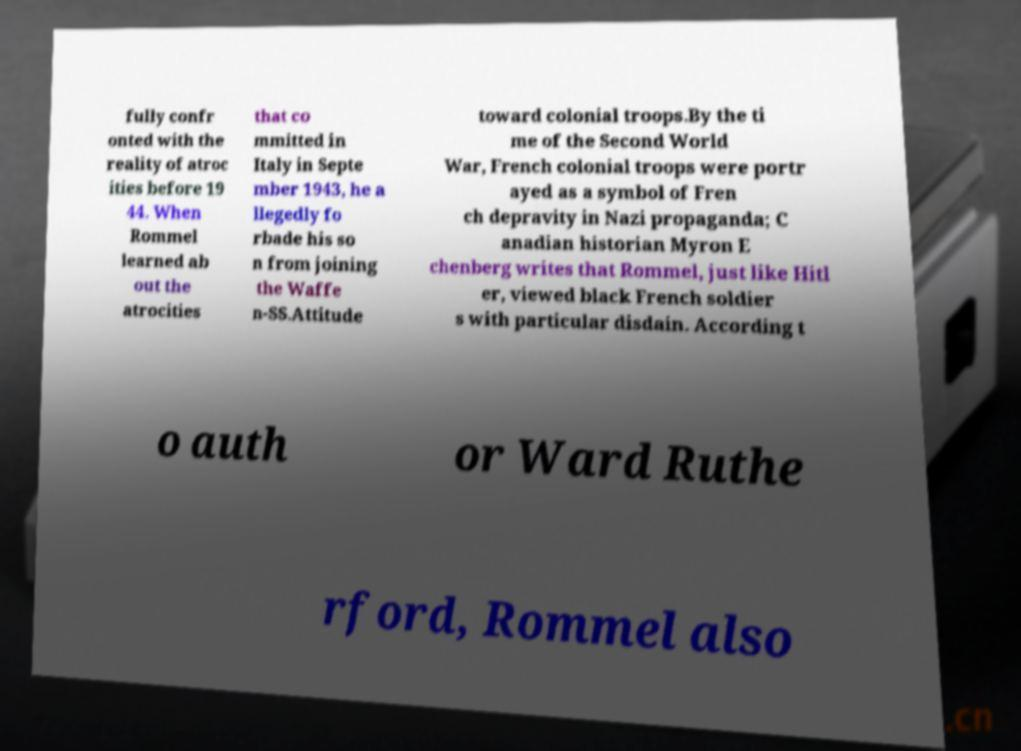I need the written content from this picture converted into text. Can you do that? fully confr onted with the reality of atroc ities before 19 44. When Rommel learned ab out the atrocities that co mmitted in Italy in Septe mber 1943, he a llegedly fo rbade his so n from joining the Waffe n-SS.Attitude toward colonial troops.By the ti me of the Second World War, French colonial troops were portr ayed as a symbol of Fren ch depravity in Nazi propaganda; C anadian historian Myron E chenberg writes that Rommel, just like Hitl er, viewed black French soldier s with particular disdain. According t o auth or Ward Ruthe rford, Rommel also 